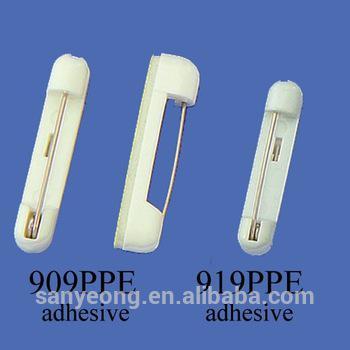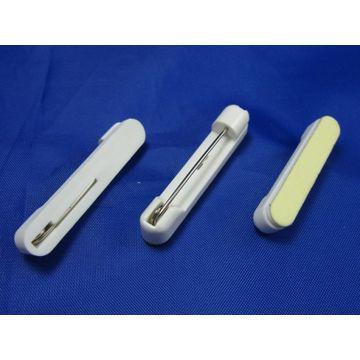The first image is the image on the left, the second image is the image on the right. Evaluate the accuracy of this statement regarding the images: "At least one safety pin is purple.". Is it true? Answer yes or no. No. 